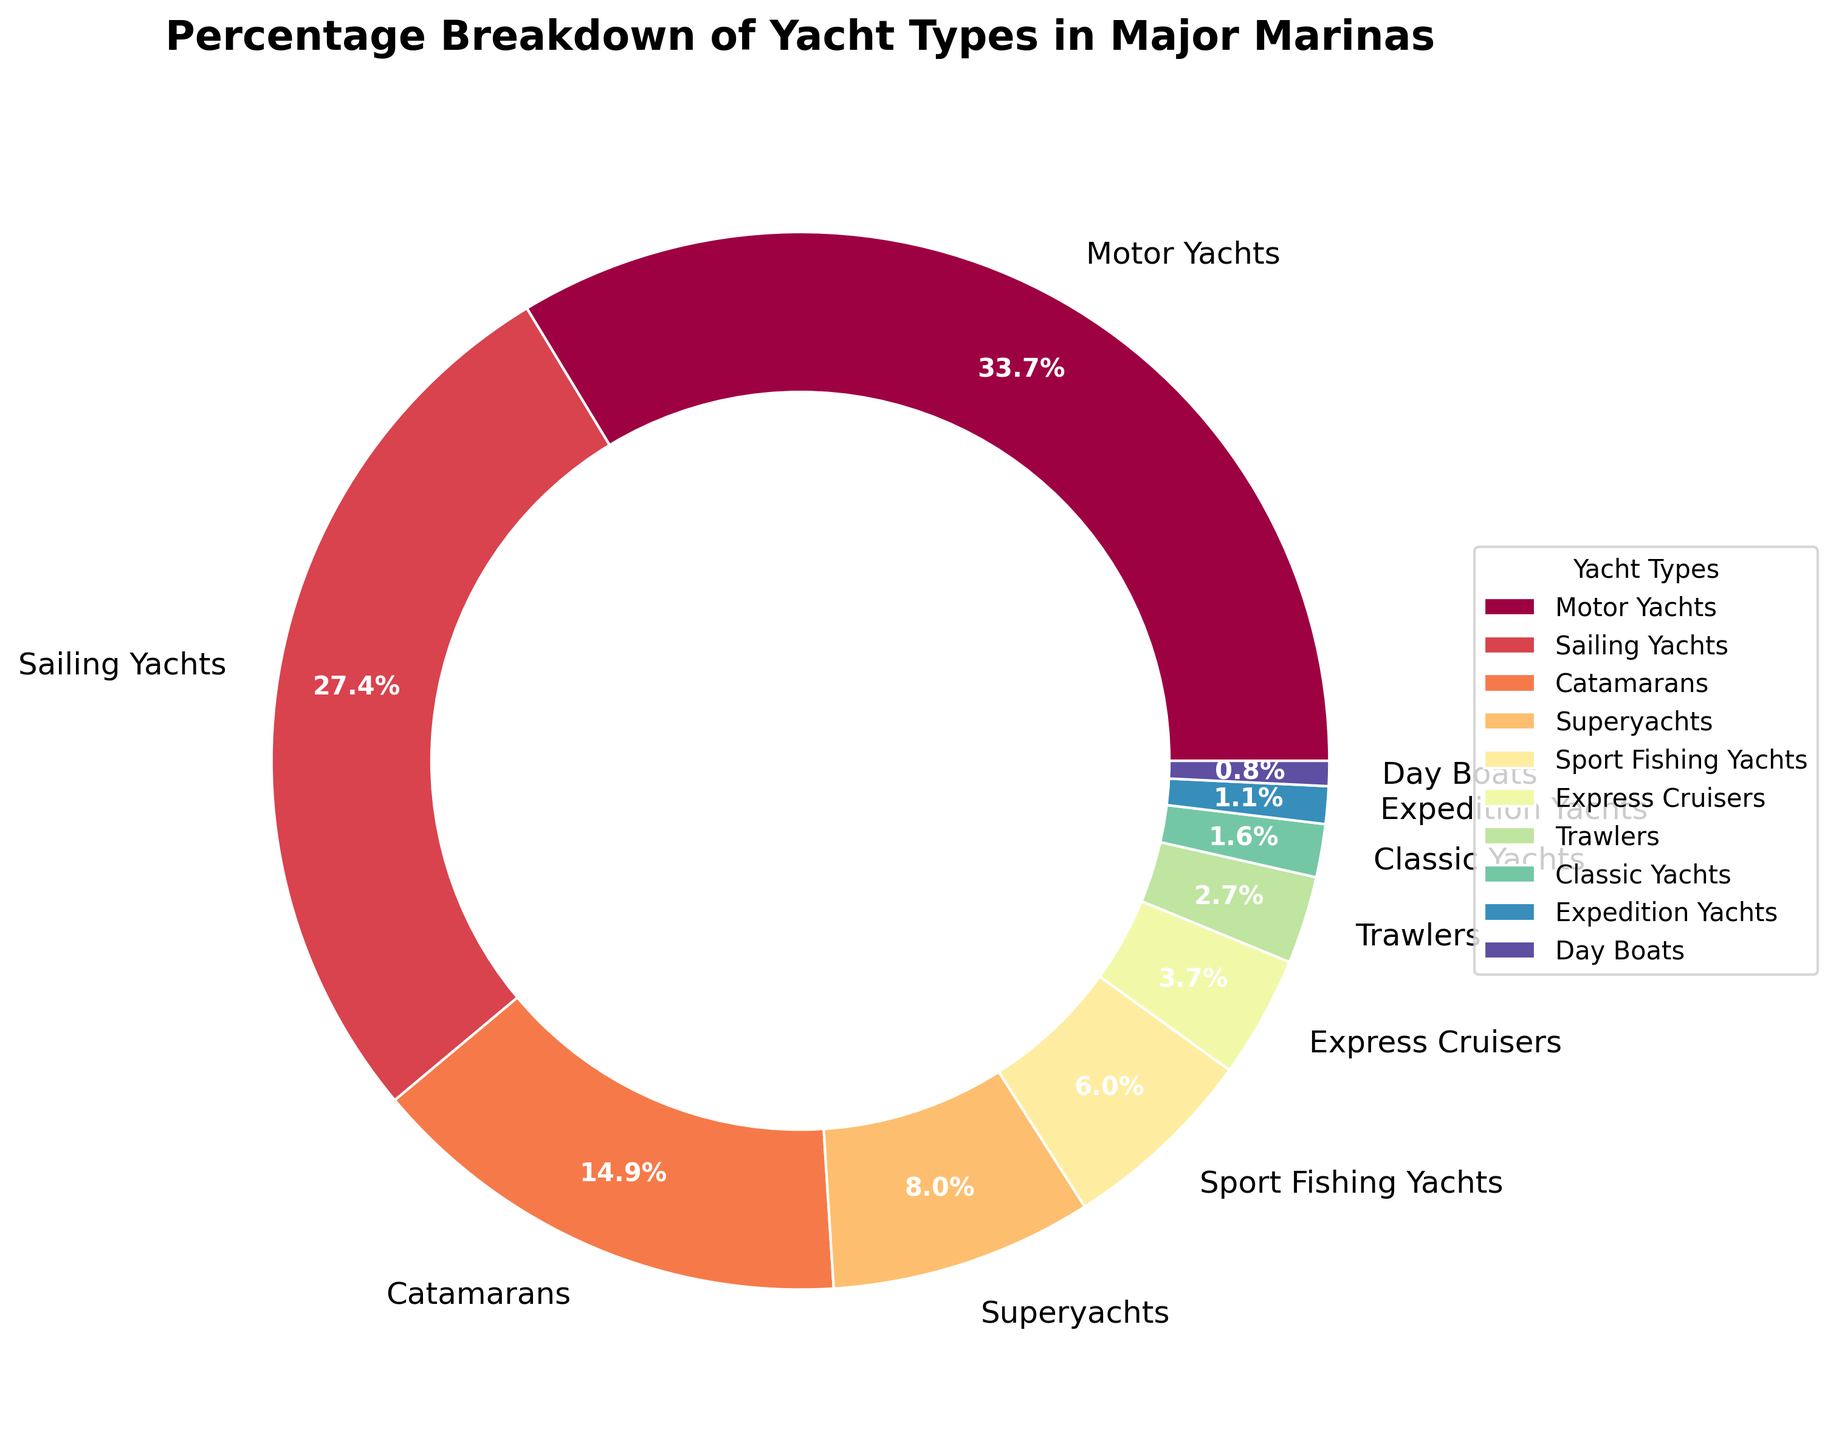What's the most common type of yacht in major marinas? By glancing at the pie chart, the largest segment can be identified. The color and label associated with this segment indicate that Motor Yachts have the highest percentage with 35.2%.
Answer: Motor Yachts Which two types of yachts together make up more than 50% of the total yachts? Adding the two largest percentage segments: Motor Yachts (35.2%) and Sailing Yachts (28.7%), we get 35.2% + 28.7% = 63.9%, which is more than 50%.
Answer: Motor Yachts and Sailing Yachts Among Catamarans and Sport Fishing Yachts, which is more prevalent, and by how much? By comparing the percentages of Catamarans (15.6%) and Sport Fishing Yachts (6.3%), the difference is 15.6% - 6.3% = 9.3%. Catamarans are more prevalent.
Answer: Catamarans by 9.3% What percentage of yachts are Superyachts and Classic Yachts combined? Adding the percentages of Superyachts (8.4%) and Classic Yachts (1.7%), we get 8.4% + 1.7% = 10.1%.
Answer: 10.1% Which type of yacht is represented by the smallest segment in the pie chart? By identifying the smallest segment visually on the chart, it corresponds to Day Boats with a percentage of 0.8%.
Answer: Day Boats What percentage of yachts are either Trawlers or Expedition Yachts? Adding the percentages of Trawlers (2.8%) and Expedition Yachts (1.2%), the sum is 2.8% + 1.2% = 4.0%.
Answer: 4.0% How does the percentage of Sailing Yachts compare to that of Superyachts? The percentage for Sailing Yachts is 28.7%, while for Superyachts, it's 8.4%. Hence, Sailing Yachts have a higher percentage.
Answer: Sailing Yachts have a higher percentage What is the combined percentage of yachts categorized under Motor Yachts, Sailing Yachts, and Catamarans? Adding the percentages of Motor Yachts (35.2%), Sailing Yachts (28.7%), and Catamarans (15.6%), we get 35.2% + 28.7% + 15.6% = 79.5%.
Answer: 79.5% Which type of yacht has around a tenth of the total percentage breakdown? Observing the chart, Superyachts have a percentage of 8.4%, which is close to 10%.
Answer: Superyachts 